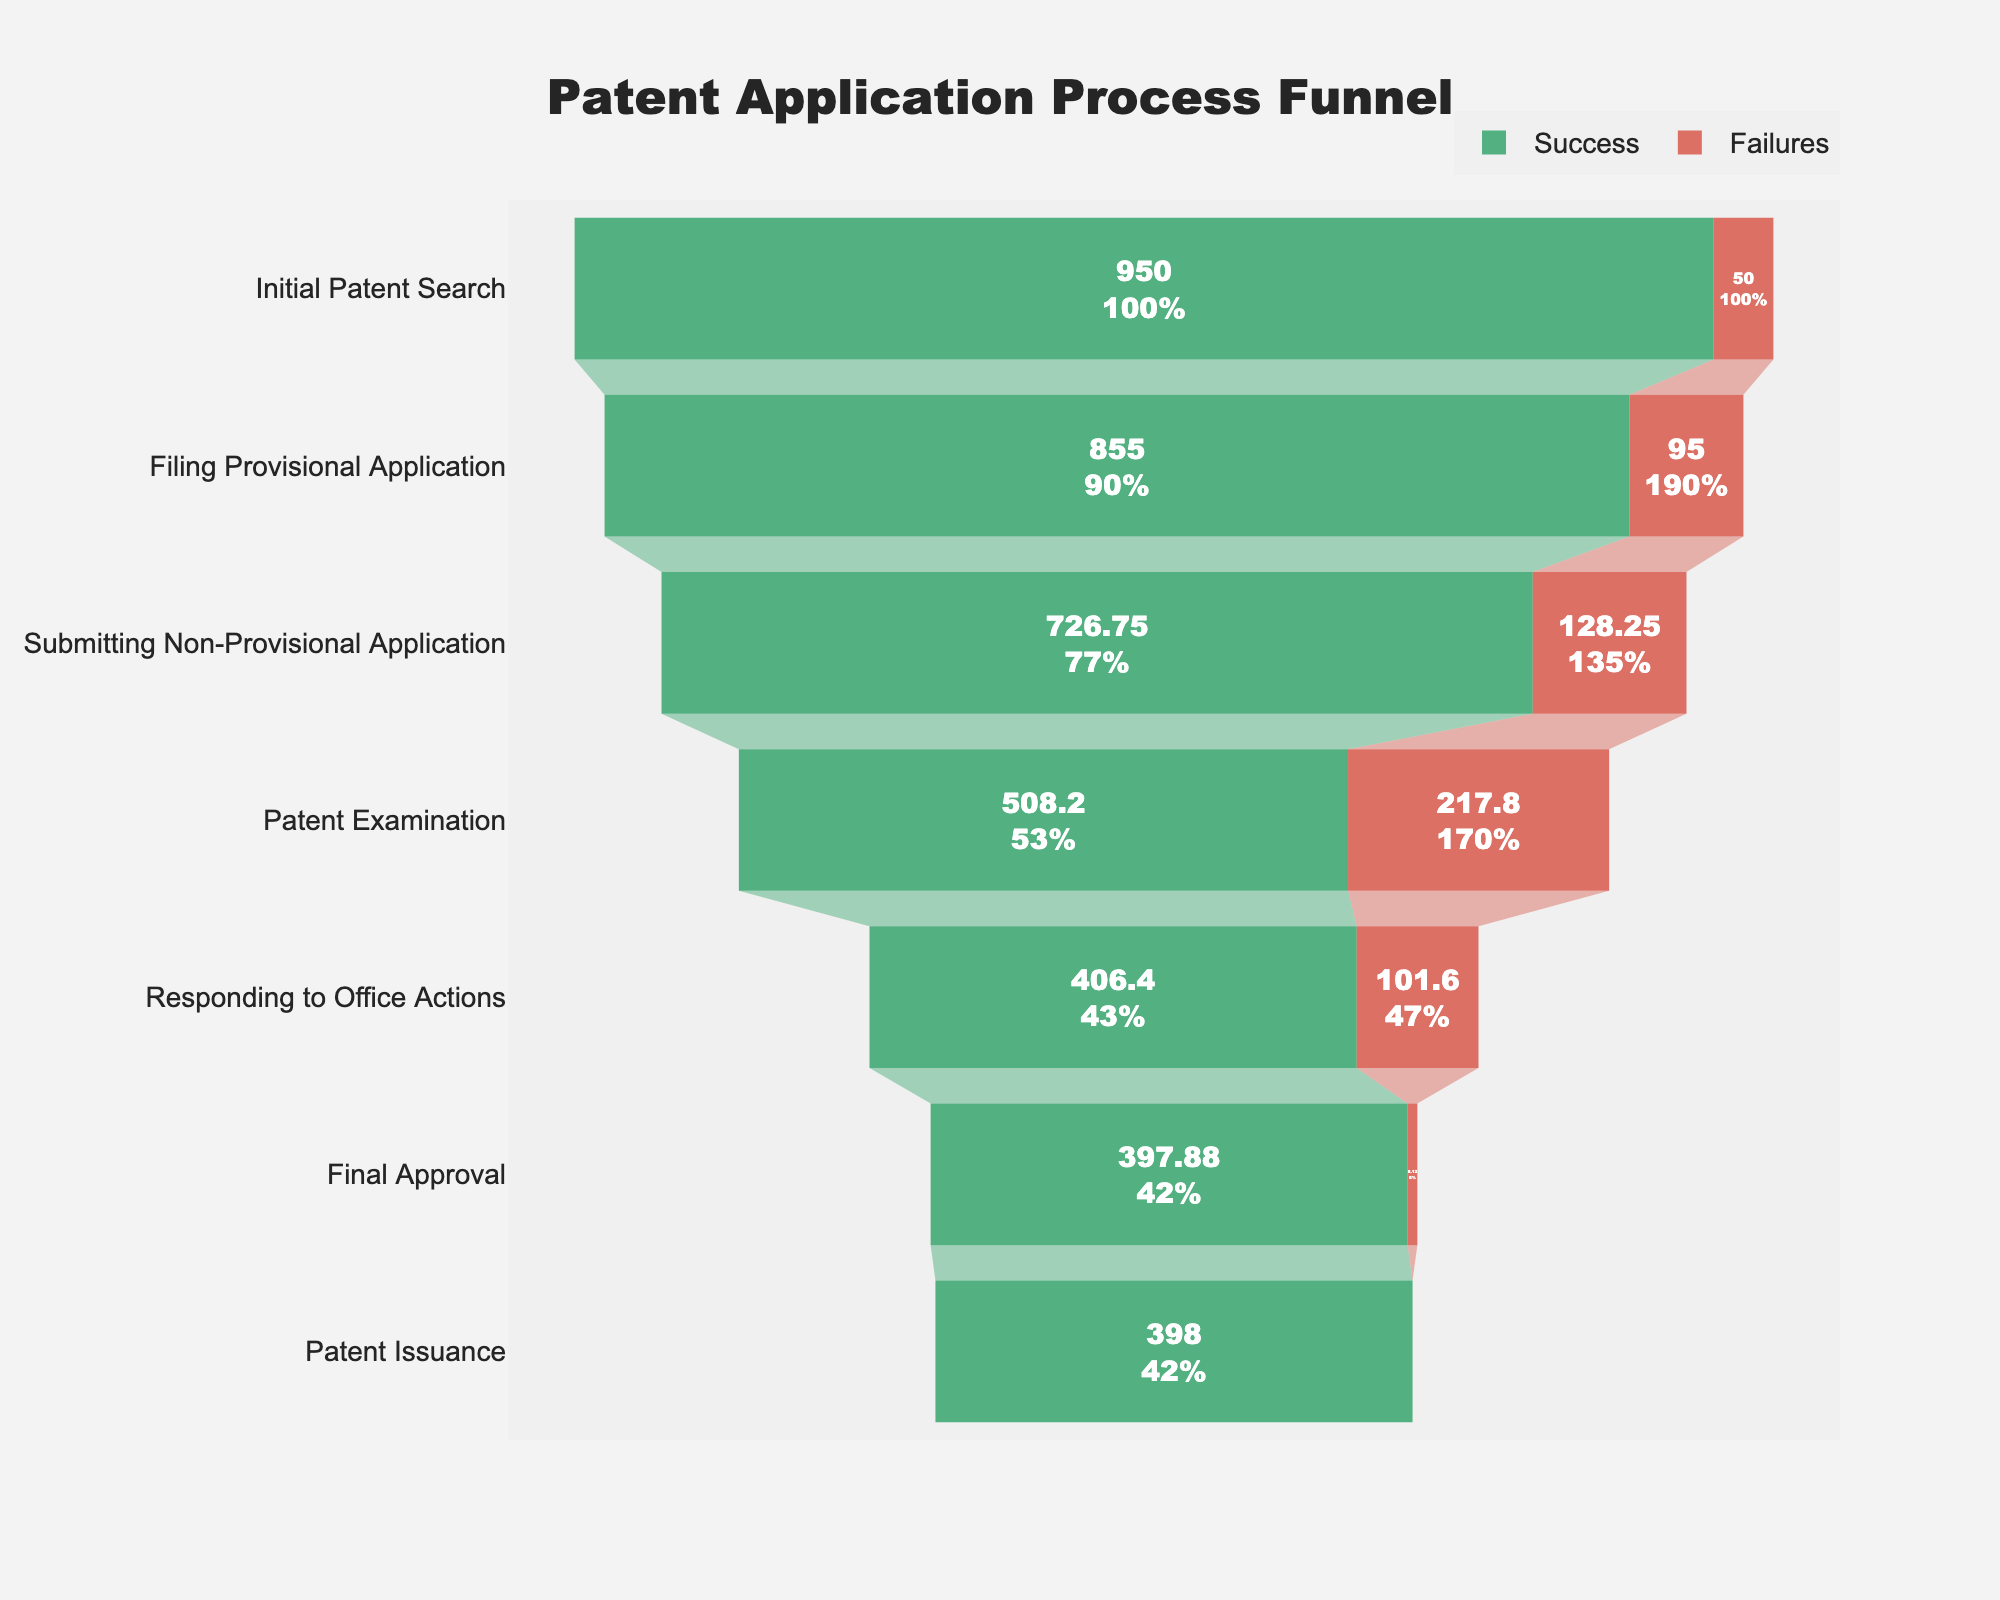What's the title of the chart? The title of the chart is usually displayed at the top of the figure. Observing the chart's layout, the title reads "Patent Application Process Funnel".
Answer: Patent Application Process Funnel How many stages are there in the patent application process? The chart typically lists the stages vertically. Counting them from top to bottom, there are 7 stages visualized.
Answer: 7 What is the success rate at the "Patent Examination" stage? By referring to the text information on the "Patent Examination" funnel, the chart indicates a success rate for this stage. It shows a 70% success rate.
Answer: 70% What is the number of successful applications at the "Filing Provisional Application" stage? The funnel segment corresponding to "Filing Provisional Application" lists the values of successful applications. This value, as indicated, is 855.
Answer: 855 Which stage has the highest success rate? Comparing the success rates visually across all the stages, the highest percentage shown is at the "Patent Issuance" stage with a 100% success rate.
Answer: Patent Issuance What is the total number of successful applications from the "Initial Patent Search" to "Final Approval"? Summing up the number of successful applications listed at each of these stages: (950 + 855 + 726 + 508 + 406) results in a total of 3445.
Answer: 3445 By how many applications does the number of failures at "Submitting Non-Provisional Application" stage exceed the failures at "Final Approval" stage? The number of failures at each stage can be calculated using the formula: Failures = Applications * (1 - Success Rate). For "Submitting Non-Provisional Application", it is 855 - (855*0.85) = 128.25. For "Final Approval", it is 406 - (406*0.98) = 8.12. The difference is 128.25 - 8.12 = 120.13
Answer: 120.13 Is there a larger drop in the number of successful applications between "Patent Examination" to "Responding to Office Actions", or from "Responding to Office Actions" to "Final Approval"? Between "Patent Examination" to "Responding to Office Actions" is 726 - 508 = 218, and from "Responding to Office Actions" to "Final Approval" is 508 - 406 = 102. The larger drop is between the former.
Answer: 218 vs 102 What percentage of initial applications reach the "Responding to Office Actions" stage successfully? The "Responding to Office Actions" stage has 508 successful applications out of the initial 1000. So, (508 / 1000) * 100 = 50.8%.
Answer: 50.8% How many total applications fail across all stages? Sum the failures across all stages: (1000 - 950) + (950 - 855) + (855 - 726) + (726 - 508) + (508 - 406) + (406 - 398) = 539.
Answer: 539 